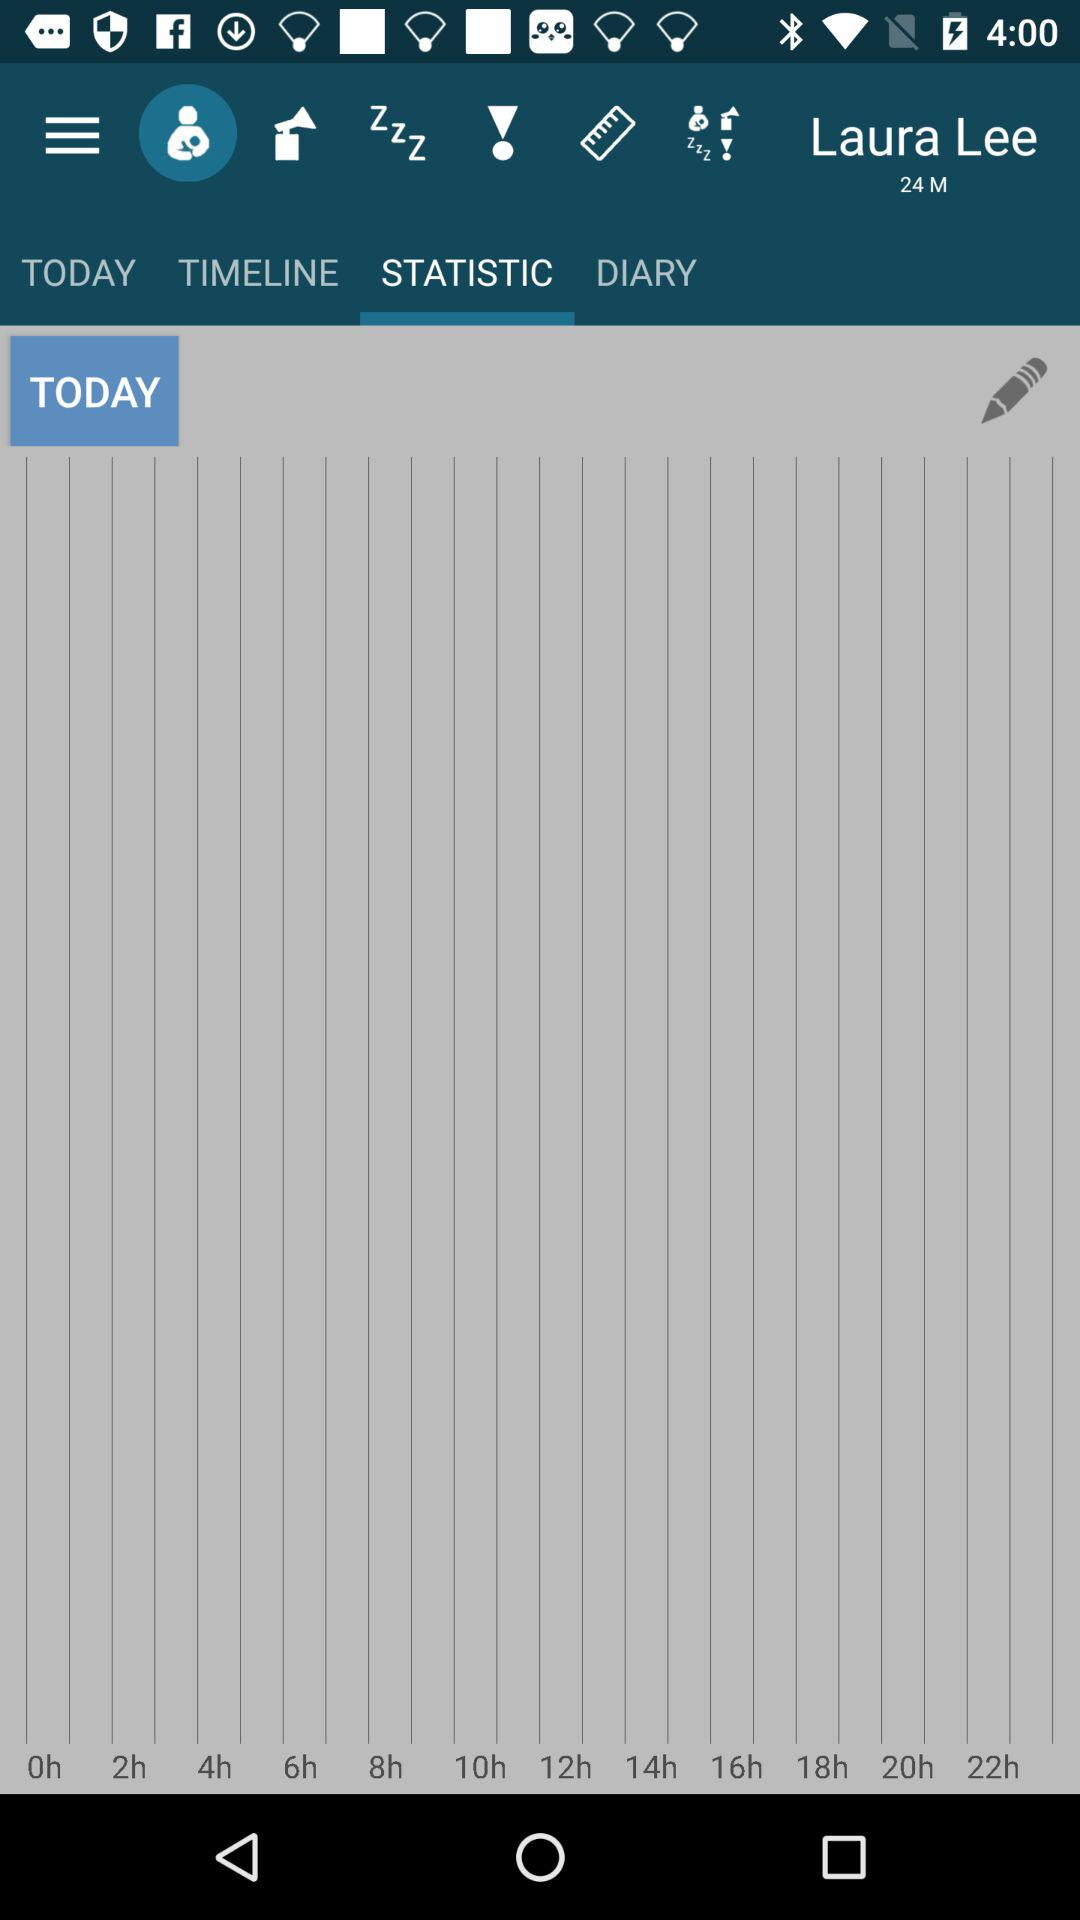What's the gender of the person? The gender is Male. 